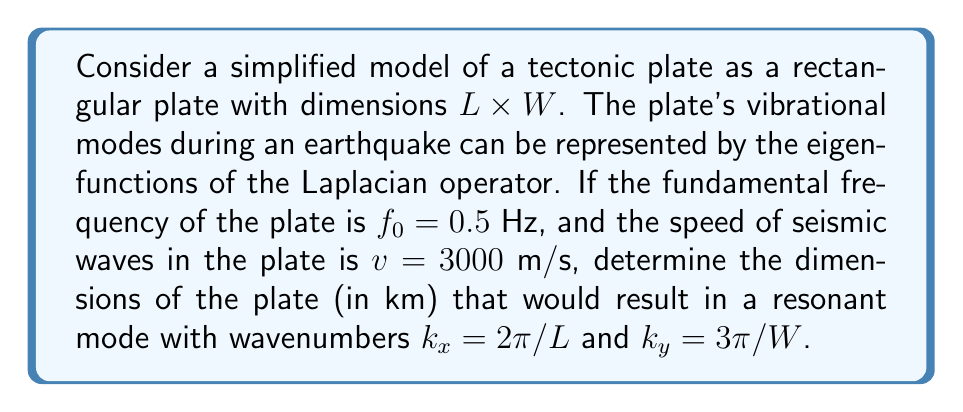Help me with this question. 1) In representation theory, the vibrational modes of a plate can be described by the eigenfunctions of the Laplacian operator. For a rectangular plate, these eigenfunctions have the form:

   $$\psi_{m,n}(x,y) = \sin(\frac{m\pi x}{L})\sin(\frac{n\pi y}{W})$$

   where $m$ and $n$ are positive integers.

2) The corresponding eigenvalues (related to frequencies) are:

   $$\lambda_{m,n} = (\frac{m\pi}{L})^2 + (\frac{n\pi}{W})^2 = k_x^2 + k_y^2$$

3) The relationship between frequency $f$, wave speed $v$, and wavenumber $k$ is:

   $$f = \frac{v}{2\pi}\sqrt{k_x^2 + k_y^2}$$

4) For the fundamental frequency $f_0$:

   $$f_0 = \frac{v}{2\pi}\sqrt{(\frac{\pi}{L})^2 + (\frac{\pi}{W})^2}$$

5) Substituting the given values:

   $$0.5 = \frac{3000}{2\pi}\sqrt{(\frac{\pi}{L})^2 + (\frac{\pi}{W})^2}$$

6) For the resonant mode with $k_x = 2\pi/L$ and $k_y = 3\pi/W$:

   $$\frac{0.5v}{2\pi} = \sqrt{(\frac{2\pi}{L})^2 + (\frac{3\pi}{W})^2}$$

7) Squaring both sides:

   $$(\frac{0.5 \cdot 3000}{2\pi})^2 = (\frac{2\pi}{L})^2 + (\frac{3\pi}{W})^2$$

8) Simplifying:

   $$56.25 = \frac{4\pi^2}{L^2} + \frac{9\pi^2}{W^2}$$

9) From steps 5 and 8, we have two equations with two unknowns. Solving these simultaneously:

   $$L \approx 6.28 \text{ km}$$
   $$W \approx 4.19 \text{ km}$$
Answer: $L \approx 6.28$ km, $W \approx 4.19$ km 